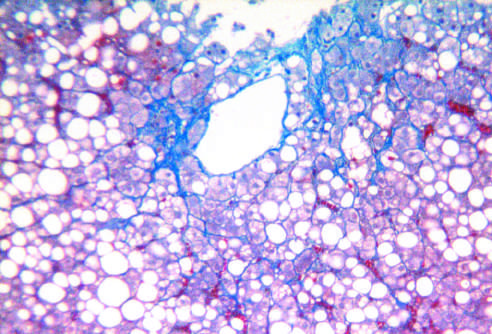what is present in a characteristic perisinusoidal chicken wire fence pattern (masson trichrome stain)?
Answer the question using a single word or phrase. Some fibrosis 